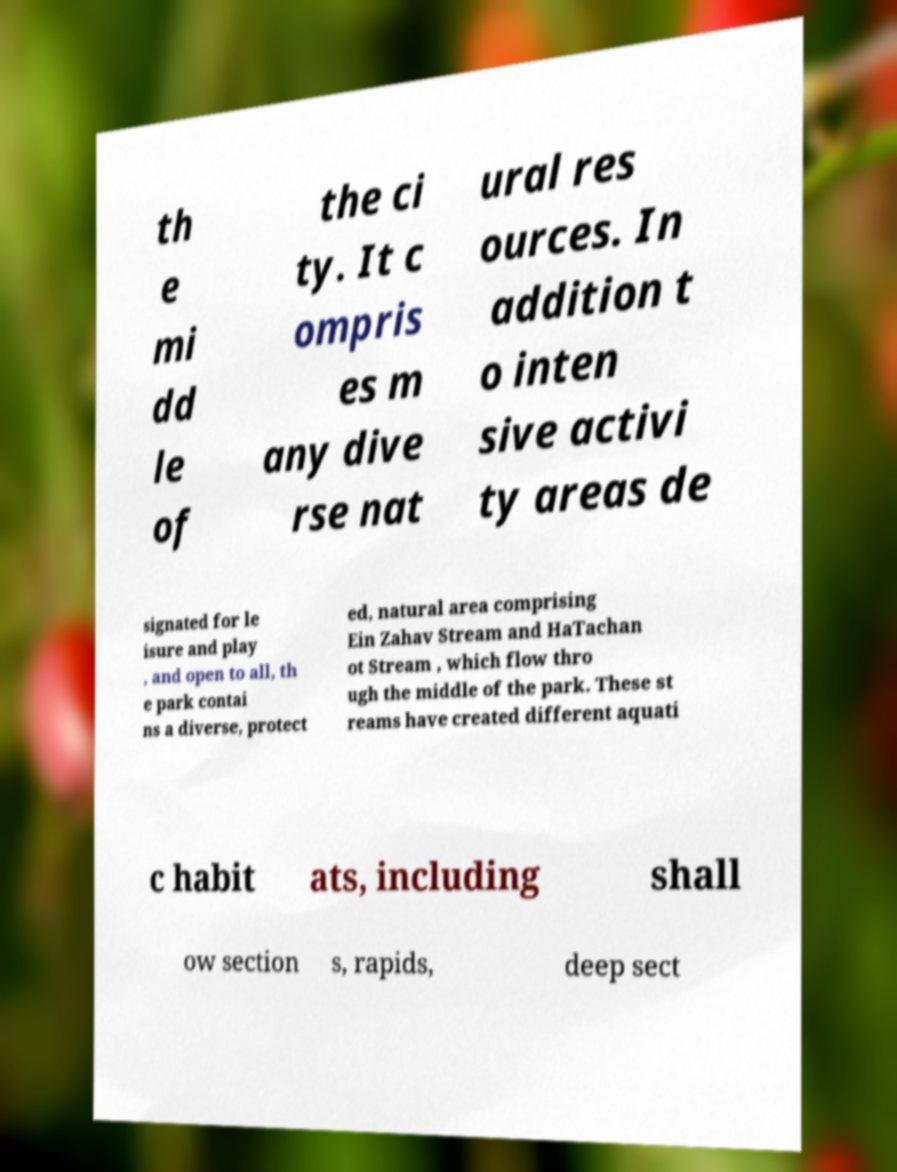Could you extract and type out the text from this image? th e mi dd le of the ci ty. It c ompris es m any dive rse nat ural res ources. In addition t o inten sive activi ty areas de signated for le isure and play , and open to all, th e park contai ns a diverse, protect ed, natural area comprising Ein Zahav Stream and HaTachan ot Stream , which flow thro ugh the middle of the park. These st reams have created different aquati c habit ats, including shall ow section s, rapids, deep sect 